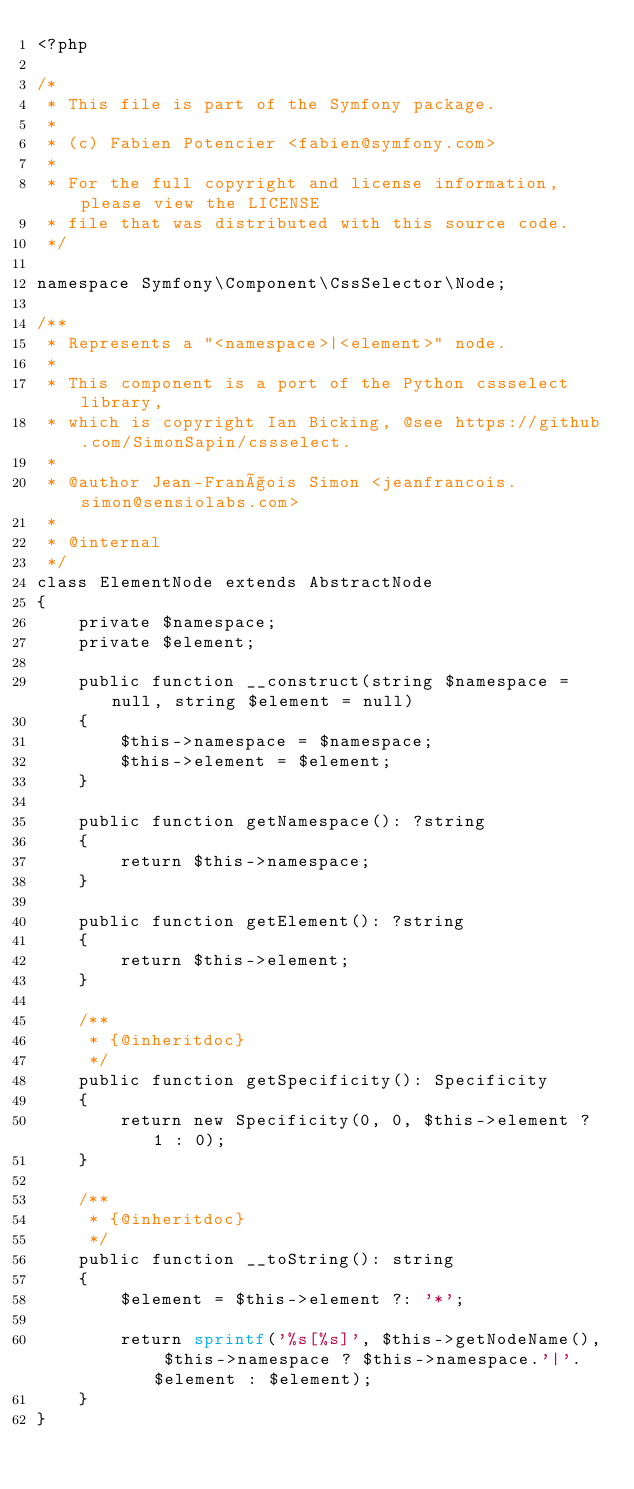Convert code to text. <code><loc_0><loc_0><loc_500><loc_500><_PHP_><?php

/*
 * This file is part of the Symfony package.
 *
 * (c) Fabien Potencier <fabien@symfony.com>
 *
 * For the full copyright and license information, please view the LICENSE
 * file that was distributed with this source code.
 */

namespace Symfony\Component\CssSelector\Node;

/**
 * Represents a "<namespace>|<element>" node.
 *
 * This component is a port of the Python cssselect library,
 * which is copyright Ian Bicking, @see https://github.com/SimonSapin/cssselect.
 *
 * @author Jean-François Simon <jeanfrancois.simon@sensiolabs.com>
 *
 * @internal
 */
class ElementNode extends AbstractNode
{
    private $namespace;
    private $element;

    public function __construct(string $namespace = null, string $element = null)
    {
        $this->namespace = $namespace;
        $this->element = $element;
    }

    public function getNamespace(): ?string
    {
        return $this->namespace;
    }

    public function getElement(): ?string
    {
        return $this->element;
    }

    /**
     * {@inheritdoc}
     */
    public function getSpecificity(): Specificity
    {
        return new Specificity(0, 0, $this->element ? 1 : 0);
    }

    /**
     * {@inheritdoc}
     */
    public function __toString(): string
    {
        $element = $this->element ?: '*';

        return sprintf('%s[%s]', $this->getNodeName(), $this->namespace ? $this->namespace.'|'.$element : $element);
    }
}
</code> 